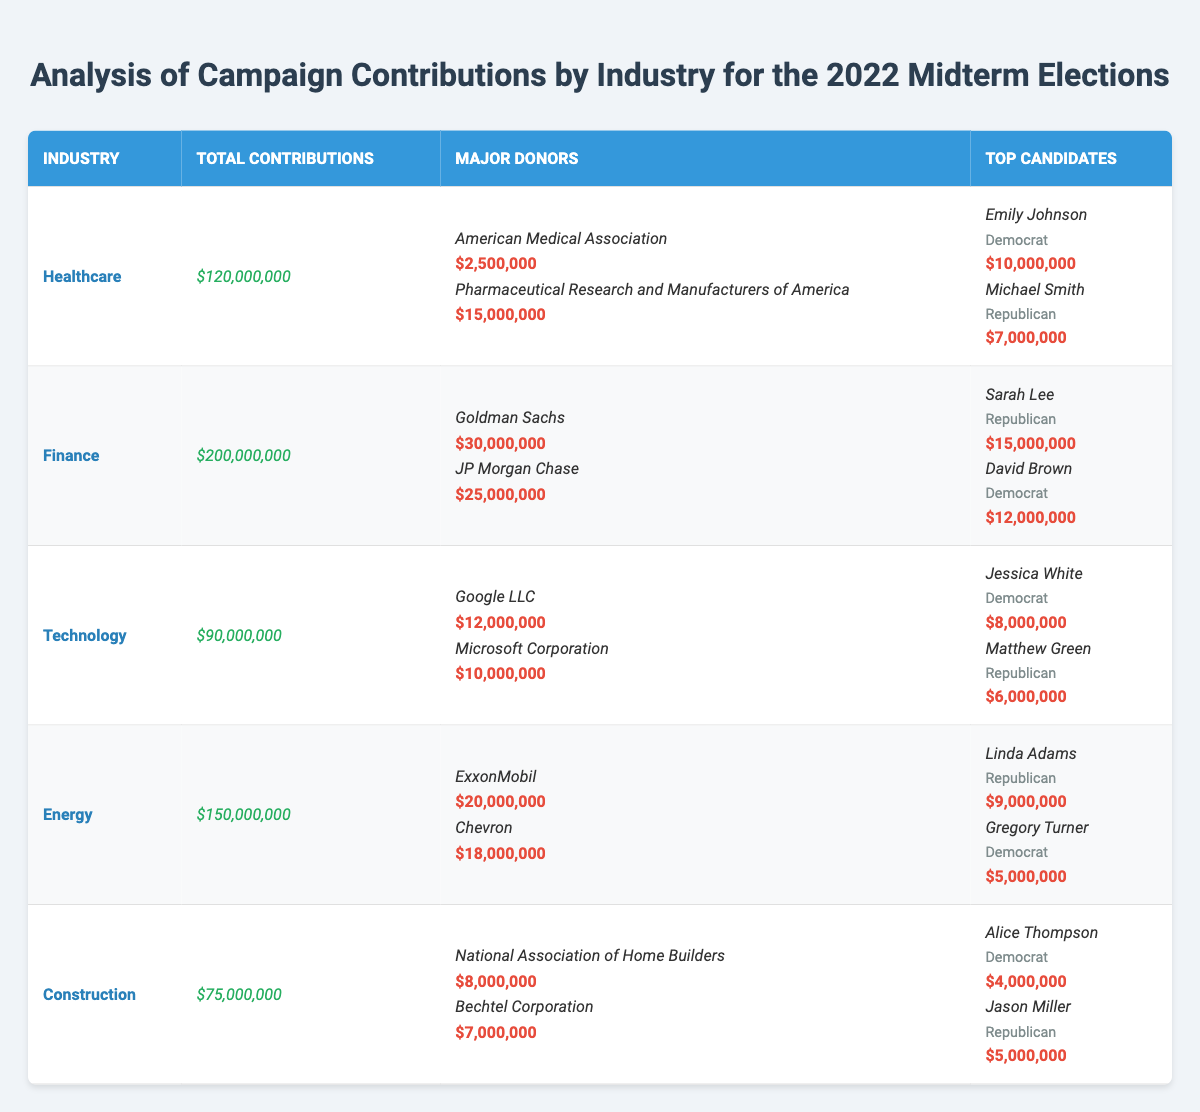What industry received the highest total contributions? Looking at the total contributions column, Finance has the highest amount at $200,000,000 compared to other industries.
Answer: Finance Who is the top candidate receiving contributions from the Healthcare industry? In the Healthcare section, Emily Johnson received $10,000,000, which is more than Michael Smith's $7,000,000.
Answer: Emily Johnson Which major donor contributed the most in the Technology industry? The major donors for Technology are listed, with Google LLC contributing $12,000,000, which is the highest amount compared to Microsoft Corporation's $10,000,000.
Answer: Google LLC What is the difference in total contributions between the Finance and Energy industries? The total contributions for Finance are $200,000,000, and for Energy, it is $150,000,000. The difference is $200,000,000 - $150,000,000 = $50,000,000.
Answer: $50,000,000 What is the average contribution received by the top two candidates in the Construction industry? The top candidates in Construction are Alice Thompson with $4,000,000 and Jason Miller with $5,000,000. Their sum is $4,000,000 + $5,000,000 = $9,000,000, and there are two candidates, so the average is $9,000,000 / 2 = $4,500,000.
Answer: $4,500,000 Did any candidates from the Democrat party receive more contributions than candidates from the Republican party in the Energy industry? Reviewing the Energy industry, Linda Adams, a Republican, received $9,000,000, and Gregory Turner, a Democrat, received $5,000,000. Since $9,000,000 (Republican) is greater than $5,000,000 (Democrat), the answer is no.
Answer: No What is the total amount contributed by the major donors in the Finance industry? The major donors for Finance are Goldman Sachs with $30,000,000 and JP Morgan Chase with $25,000,000. Adding these gives $30,000,000 + $25,000,000 = $55,000,000.
Answer: $55,000,000 Which industry had the lowest total contributions and what was that amount? By comparing the total contributions, Construction had the lowest total at $75,000,000.
Answer: Construction, $75,000,000 If we combine the top two candidates in the Healthcare and Technology industries, what is their total amount received? The top candidates in Healthcare are Emily Johnson with $10,000,000 and Michael Smith with $7,000,000, totaling $17,000,000. In Technology, Jessica White received $8,000,000 and Matthew Green received $6,000,000, which totals $14,000,000. Combining both totals, $17,000,000 + $14,000,000 = $31,000,000.
Answer: $31,000,000 Is it true that the top recipient in the Finance industry received more than the top recipient in the Healthcare industry? The top recipient in Finance is Sarah Lee with $15,000,000, and the top recipient in Healthcare is Emily Johnson with $10,000,000. Since $15,000,000 is greater than $10,000,000, the statement is true.
Answer: Yes 